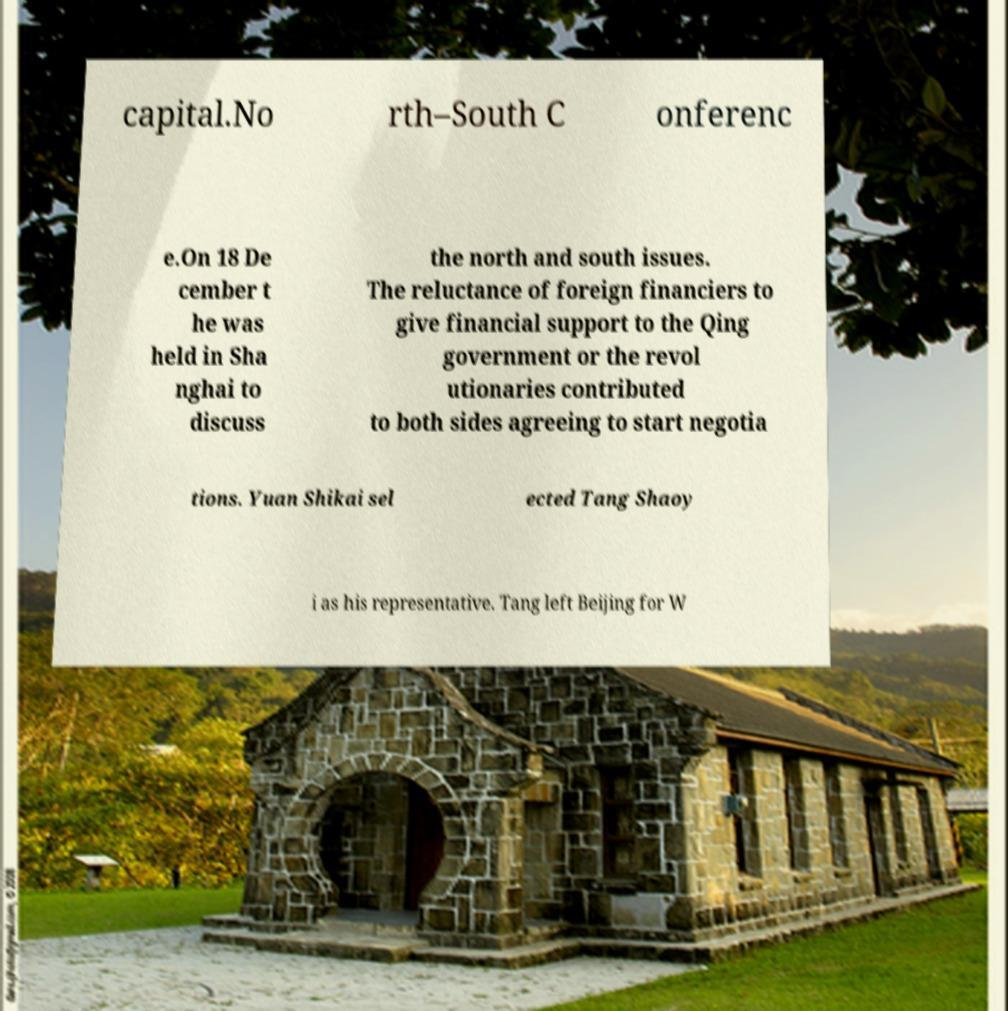Can you read and provide the text displayed in the image?This photo seems to have some interesting text. Can you extract and type it out for me? capital.No rth–South C onferenc e.On 18 De cember t he was held in Sha nghai to discuss the north and south issues. The reluctance of foreign financiers to give financial support to the Qing government or the revol utionaries contributed to both sides agreeing to start negotia tions. Yuan Shikai sel ected Tang Shaoy i as his representative. Tang left Beijing for W 